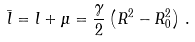<formula> <loc_0><loc_0><loc_500><loc_500>\bar { l } = l + \mu = \frac { \gamma } { 2 } \left ( R ^ { 2 } - R _ { 0 } ^ { 2 } \right ) \, .</formula> 